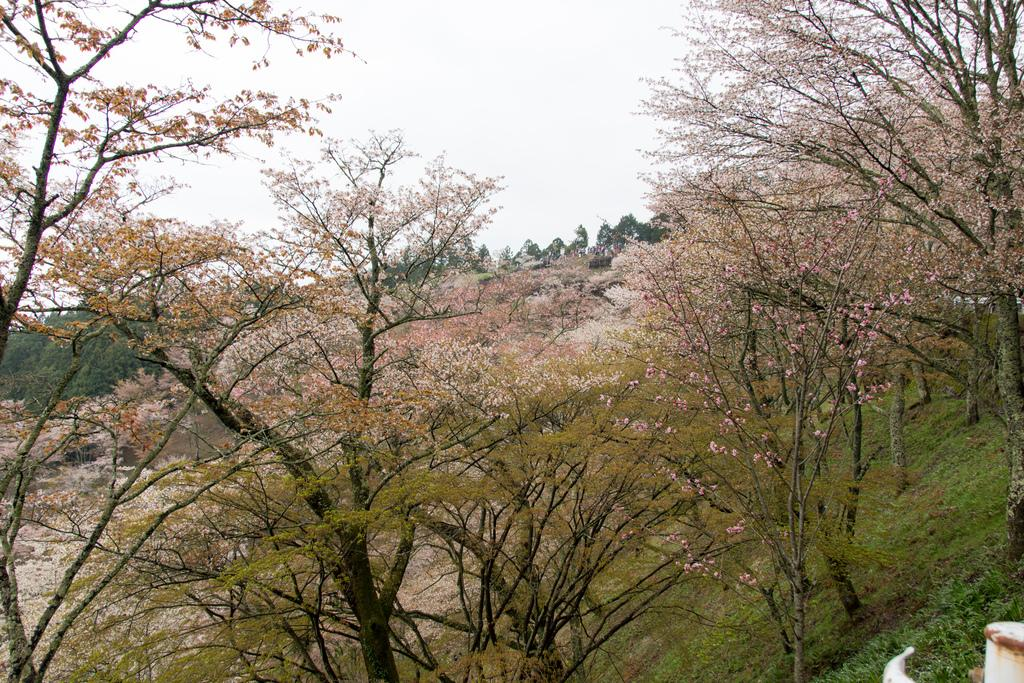What is located in the center of the image? There are trees in the center of the image. What is visible at the top of the image? The sky is visible at the top of the image. How many eyes can be seen on the trees in the image? Trees do not have eyes, so there are no eyes visible on the trees in the image. 